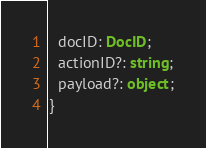<code> <loc_0><loc_0><loc_500><loc_500><_TypeScript_>  docID: DocID;
  actionID?: string;
  payload?: object;
}
</code> 